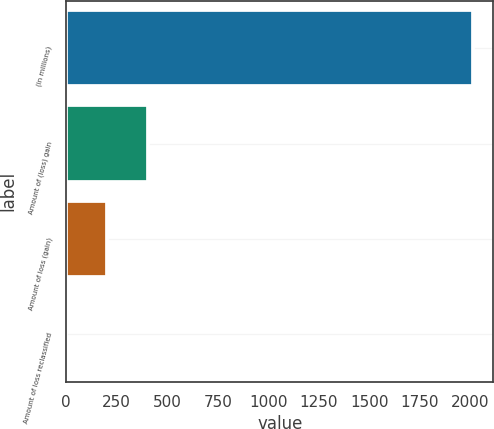Convert chart. <chart><loc_0><loc_0><loc_500><loc_500><bar_chart><fcel>(in millions)<fcel>Amount of (loss) gain<fcel>Amount of loss (gain)<fcel>Amount of loss reclassified<nl><fcel>2014<fcel>403.6<fcel>202.3<fcel>1<nl></chart> 